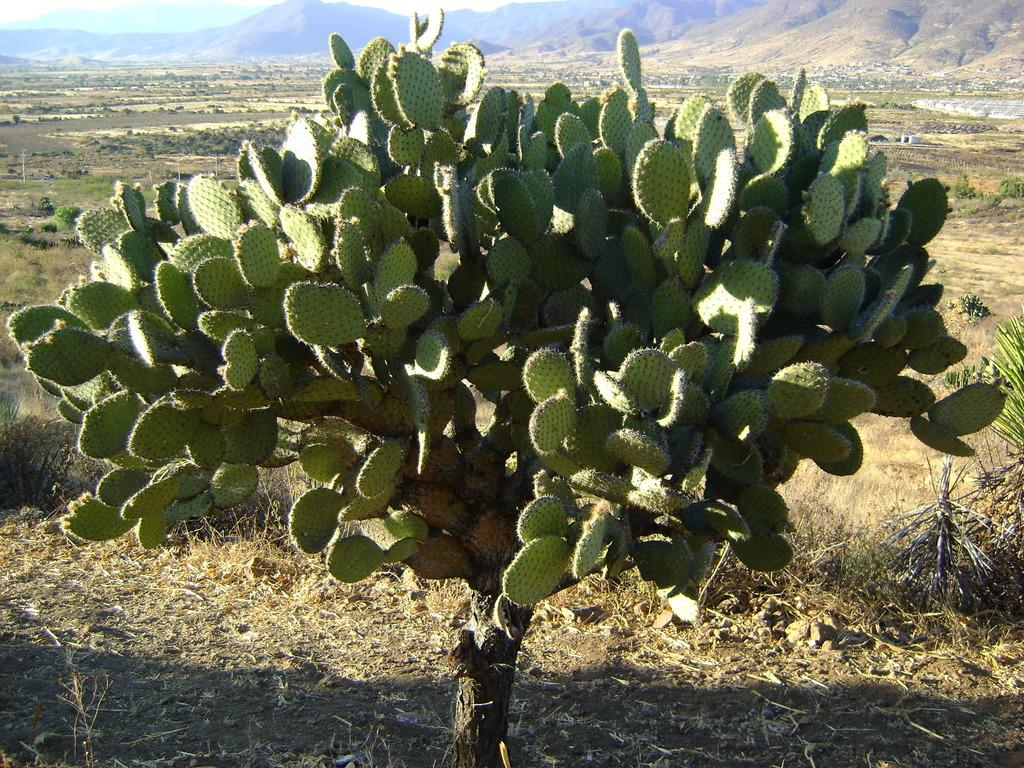What type of plant is in the image? There is a green cactus plant in the image. Where is the cactus plant located in the image? The cactus plant is in the front of the image. What can be seen beneath the cactus plant? There is ground visible in the image. What is visible in the distance behind the cactus plant? There are mountains in the background of the image. What type of marble is used to decorate the cactus plant in the image? There is no marble present in the image; it features a green cactus plant with ground and mountains in the background. 